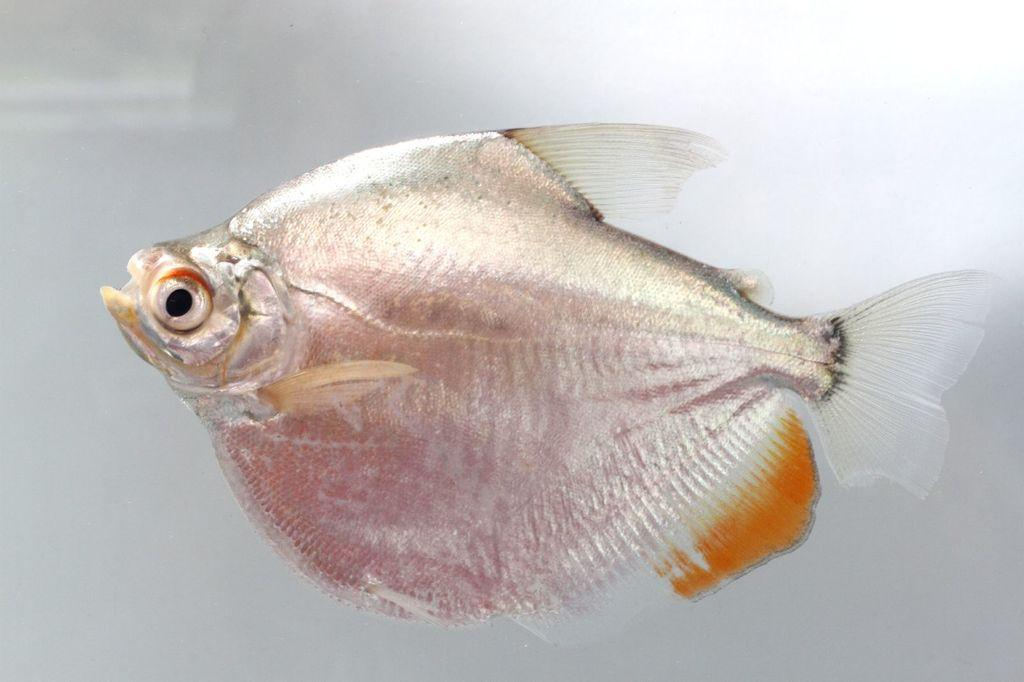What type of animal is present in the image? There is a fish in the image. How does the fish use its grip to push the scarf in the image? There is no scarf present in the image, and fish do not have the ability to grip or push objects. 